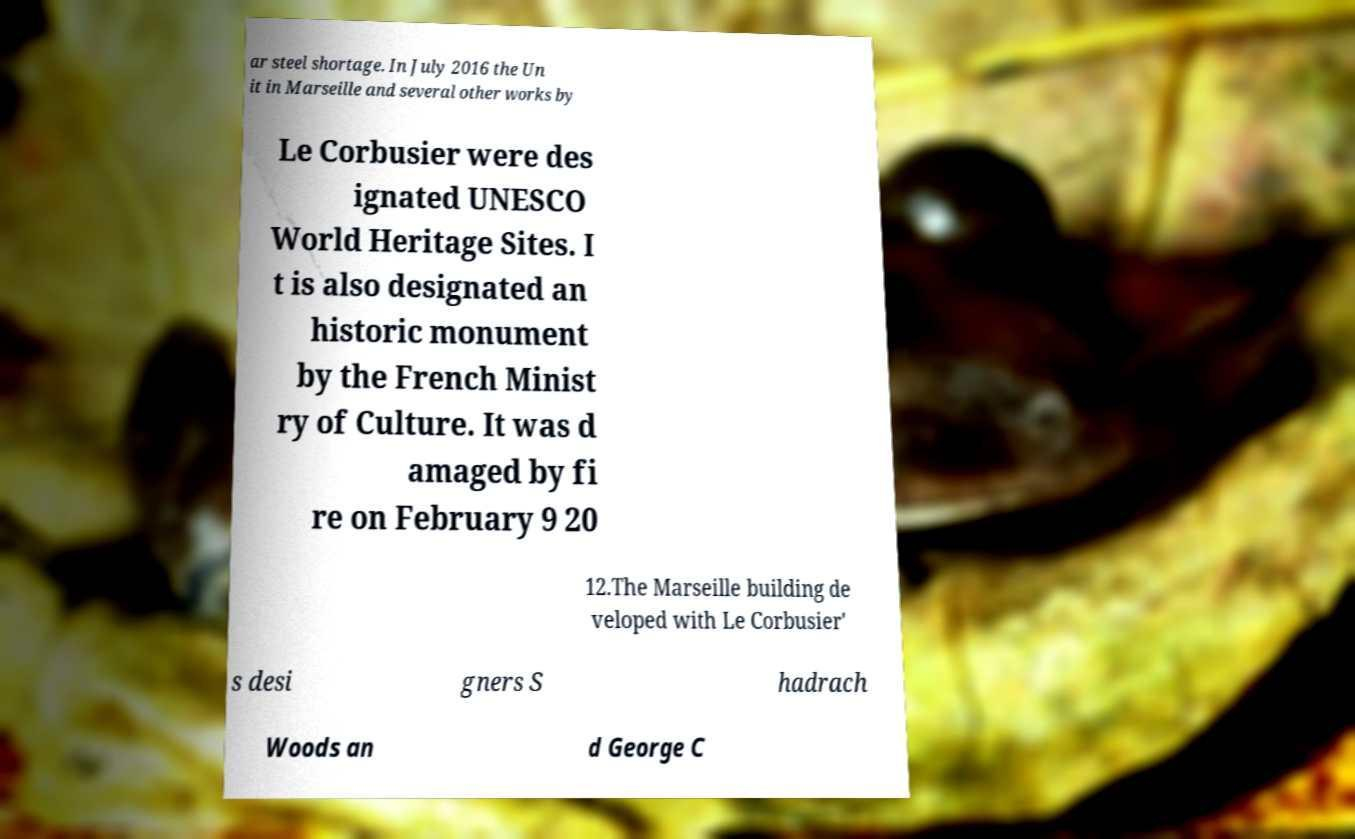Please read and relay the text visible in this image. What does it say? ar steel shortage. In July 2016 the Un it in Marseille and several other works by Le Corbusier were des ignated UNESCO World Heritage Sites. I t is also designated an historic monument by the French Minist ry of Culture. It was d amaged by fi re on February 9 20 12.The Marseille building de veloped with Le Corbusier' s desi gners S hadrach Woods an d George C 